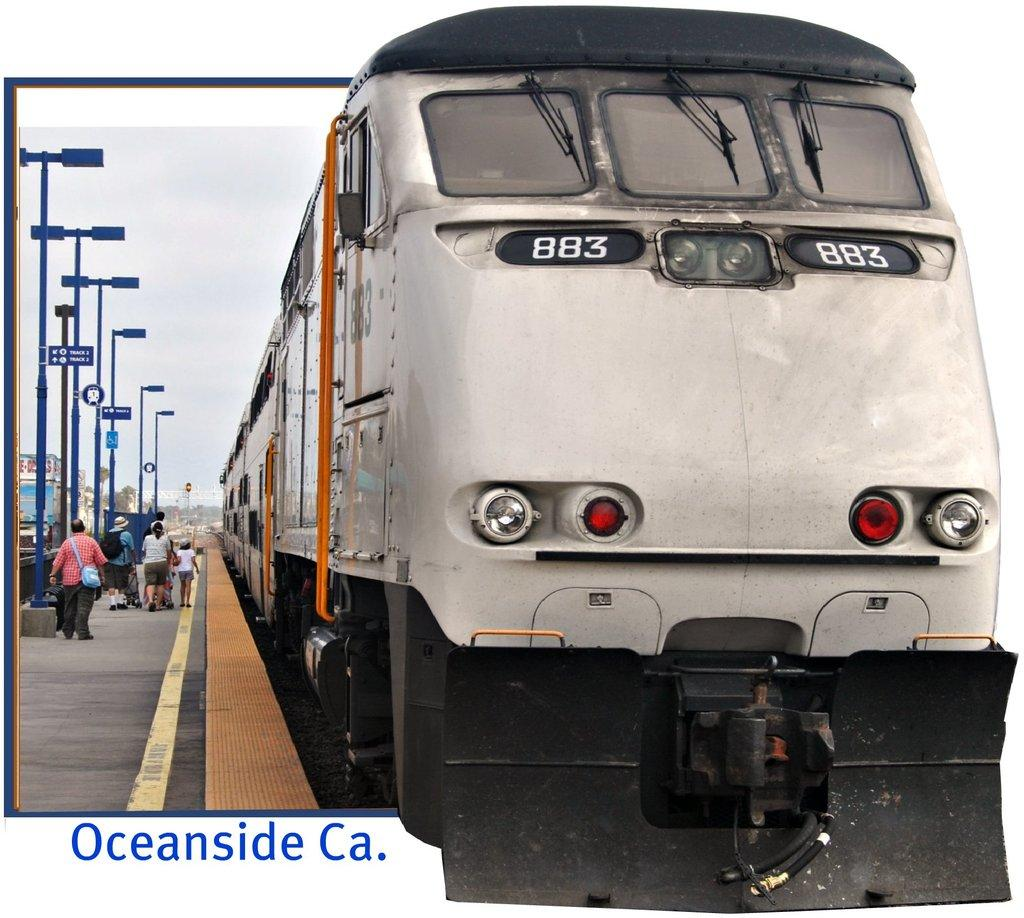<image>
Create a compact narrative representing the image presented. A photo of a white train with caption that says "Oceanside Ca.". 